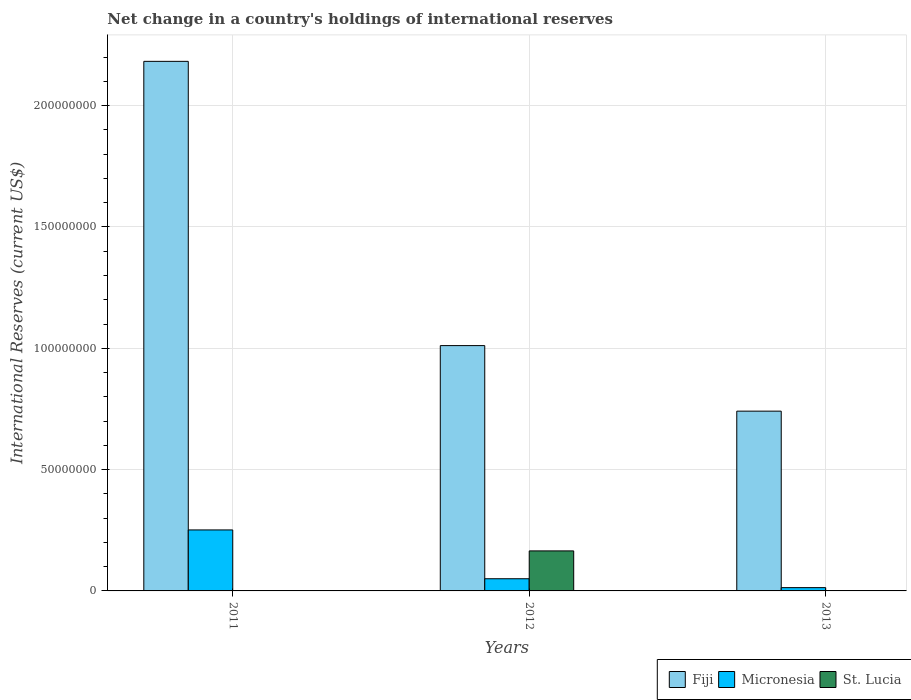How many groups of bars are there?
Provide a succinct answer. 3. Are the number of bars per tick equal to the number of legend labels?
Ensure brevity in your answer.  No. Are the number of bars on each tick of the X-axis equal?
Keep it short and to the point. No. How many bars are there on the 3rd tick from the right?
Provide a succinct answer. 2. What is the international reserves in Fiji in 2011?
Keep it short and to the point. 2.18e+08. Across all years, what is the maximum international reserves in Fiji?
Make the answer very short. 2.18e+08. Across all years, what is the minimum international reserves in Fiji?
Offer a very short reply. 7.41e+07. In which year was the international reserves in Micronesia maximum?
Provide a succinct answer. 2011. What is the total international reserves in Micronesia in the graph?
Provide a succinct answer. 3.15e+07. What is the difference between the international reserves in Micronesia in 2011 and that in 2012?
Your response must be concise. 2.01e+07. What is the difference between the international reserves in Fiji in 2011 and the international reserves in Micronesia in 2012?
Provide a short and direct response. 2.13e+08. What is the average international reserves in Micronesia per year?
Make the answer very short. 1.05e+07. In the year 2012, what is the difference between the international reserves in Fiji and international reserves in Micronesia?
Make the answer very short. 9.61e+07. In how many years, is the international reserves in Fiji greater than 160000000 US$?
Provide a succinct answer. 1. What is the ratio of the international reserves in Fiji in 2011 to that in 2012?
Your response must be concise. 2.16. Is the difference between the international reserves in Fiji in 2012 and 2013 greater than the difference between the international reserves in Micronesia in 2012 and 2013?
Keep it short and to the point. Yes. What is the difference between the highest and the second highest international reserves in Fiji?
Ensure brevity in your answer.  1.17e+08. What is the difference between the highest and the lowest international reserves in Fiji?
Give a very brief answer. 1.44e+08. Is the sum of the international reserves in Fiji in 2011 and 2012 greater than the maximum international reserves in Micronesia across all years?
Keep it short and to the point. Yes. Is it the case that in every year, the sum of the international reserves in St. Lucia and international reserves in Micronesia is greater than the international reserves in Fiji?
Keep it short and to the point. No. Does the graph contain grids?
Ensure brevity in your answer.  Yes. How are the legend labels stacked?
Keep it short and to the point. Horizontal. What is the title of the graph?
Your response must be concise. Net change in a country's holdings of international reserves. What is the label or title of the Y-axis?
Ensure brevity in your answer.  International Reserves (current US$). What is the International Reserves (current US$) in Fiji in 2011?
Offer a terse response. 2.18e+08. What is the International Reserves (current US$) in Micronesia in 2011?
Your response must be concise. 2.51e+07. What is the International Reserves (current US$) of St. Lucia in 2011?
Provide a short and direct response. 0. What is the International Reserves (current US$) of Fiji in 2012?
Ensure brevity in your answer.  1.01e+08. What is the International Reserves (current US$) of Micronesia in 2012?
Offer a very short reply. 5.02e+06. What is the International Reserves (current US$) of St. Lucia in 2012?
Keep it short and to the point. 1.65e+07. What is the International Reserves (current US$) of Fiji in 2013?
Ensure brevity in your answer.  7.41e+07. What is the International Reserves (current US$) in Micronesia in 2013?
Your answer should be compact. 1.35e+06. Across all years, what is the maximum International Reserves (current US$) in Fiji?
Provide a succinct answer. 2.18e+08. Across all years, what is the maximum International Reserves (current US$) in Micronesia?
Give a very brief answer. 2.51e+07. Across all years, what is the maximum International Reserves (current US$) in St. Lucia?
Offer a very short reply. 1.65e+07. Across all years, what is the minimum International Reserves (current US$) in Fiji?
Provide a short and direct response. 7.41e+07. Across all years, what is the minimum International Reserves (current US$) in Micronesia?
Your answer should be compact. 1.35e+06. What is the total International Reserves (current US$) of Fiji in the graph?
Offer a terse response. 3.93e+08. What is the total International Reserves (current US$) of Micronesia in the graph?
Offer a very short reply. 3.15e+07. What is the total International Reserves (current US$) in St. Lucia in the graph?
Offer a very short reply. 1.65e+07. What is the difference between the International Reserves (current US$) in Fiji in 2011 and that in 2012?
Make the answer very short. 1.17e+08. What is the difference between the International Reserves (current US$) in Micronesia in 2011 and that in 2012?
Offer a very short reply. 2.01e+07. What is the difference between the International Reserves (current US$) in Fiji in 2011 and that in 2013?
Keep it short and to the point. 1.44e+08. What is the difference between the International Reserves (current US$) of Micronesia in 2011 and that in 2013?
Provide a succinct answer. 2.38e+07. What is the difference between the International Reserves (current US$) in Fiji in 2012 and that in 2013?
Give a very brief answer. 2.70e+07. What is the difference between the International Reserves (current US$) of Micronesia in 2012 and that in 2013?
Offer a terse response. 3.66e+06. What is the difference between the International Reserves (current US$) of Fiji in 2011 and the International Reserves (current US$) of Micronesia in 2012?
Offer a very short reply. 2.13e+08. What is the difference between the International Reserves (current US$) in Fiji in 2011 and the International Reserves (current US$) in St. Lucia in 2012?
Your response must be concise. 2.02e+08. What is the difference between the International Reserves (current US$) in Micronesia in 2011 and the International Reserves (current US$) in St. Lucia in 2012?
Provide a short and direct response. 8.64e+06. What is the difference between the International Reserves (current US$) in Fiji in 2011 and the International Reserves (current US$) in Micronesia in 2013?
Your answer should be very brief. 2.17e+08. What is the difference between the International Reserves (current US$) of Fiji in 2012 and the International Reserves (current US$) of Micronesia in 2013?
Make the answer very short. 9.97e+07. What is the average International Reserves (current US$) in Fiji per year?
Provide a succinct answer. 1.31e+08. What is the average International Reserves (current US$) of Micronesia per year?
Your answer should be very brief. 1.05e+07. What is the average International Reserves (current US$) in St. Lucia per year?
Provide a succinct answer. 5.50e+06. In the year 2011, what is the difference between the International Reserves (current US$) of Fiji and International Reserves (current US$) of Micronesia?
Make the answer very short. 1.93e+08. In the year 2012, what is the difference between the International Reserves (current US$) in Fiji and International Reserves (current US$) in Micronesia?
Ensure brevity in your answer.  9.61e+07. In the year 2012, what is the difference between the International Reserves (current US$) of Fiji and International Reserves (current US$) of St. Lucia?
Your response must be concise. 8.46e+07. In the year 2012, what is the difference between the International Reserves (current US$) in Micronesia and International Reserves (current US$) in St. Lucia?
Ensure brevity in your answer.  -1.15e+07. In the year 2013, what is the difference between the International Reserves (current US$) of Fiji and International Reserves (current US$) of Micronesia?
Ensure brevity in your answer.  7.27e+07. What is the ratio of the International Reserves (current US$) of Fiji in 2011 to that in 2012?
Offer a very short reply. 2.16. What is the ratio of the International Reserves (current US$) of Micronesia in 2011 to that in 2012?
Offer a terse response. 5.01. What is the ratio of the International Reserves (current US$) in Fiji in 2011 to that in 2013?
Your response must be concise. 2.95. What is the ratio of the International Reserves (current US$) of Micronesia in 2011 to that in 2013?
Your answer should be very brief. 18.55. What is the ratio of the International Reserves (current US$) of Fiji in 2012 to that in 2013?
Offer a terse response. 1.36. What is the ratio of the International Reserves (current US$) of Micronesia in 2012 to that in 2013?
Ensure brevity in your answer.  3.7. What is the difference between the highest and the second highest International Reserves (current US$) in Fiji?
Provide a succinct answer. 1.17e+08. What is the difference between the highest and the second highest International Reserves (current US$) in Micronesia?
Ensure brevity in your answer.  2.01e+07. What is the difference between the highest and the lowest International Reserves (current US$) of Fiji?
Provide a succinct answer. 1.44e+08. What is the difference between the highest and the lowest International Reserves (current US$) of Micronesia?
Keep it short and to the point. 2.38e+07. What is the difference between the highest and the lowest International Reserves (current US$) in St. Lucia?
Provide a short and direct response. 1.65e+07. 